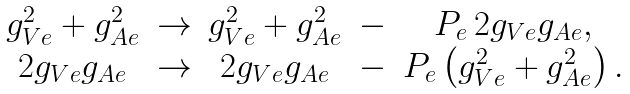<formula> <loc_0><loc_0><loc_500><loc_500>\begin{array} { c l c l c } g ^ { 2 } _ { V e } + g ^ { 2 } _ { A e } & \rightarrow & g ^ { 2 } _ { V e } + g ^ { 2 } _ { A e } & - & P _ { e } \, 2 g _ { V e } g _ { A e } , \\ 2 g _ { V e } g _ { A e } & \rightarrow & 2 g _ { V e } g _ { A e } & - & P _ { e } \left ( g ^ { 2 } _ { V e } + g ^ { 2 } _ { A e } \right ) . \end{array}</formula> 